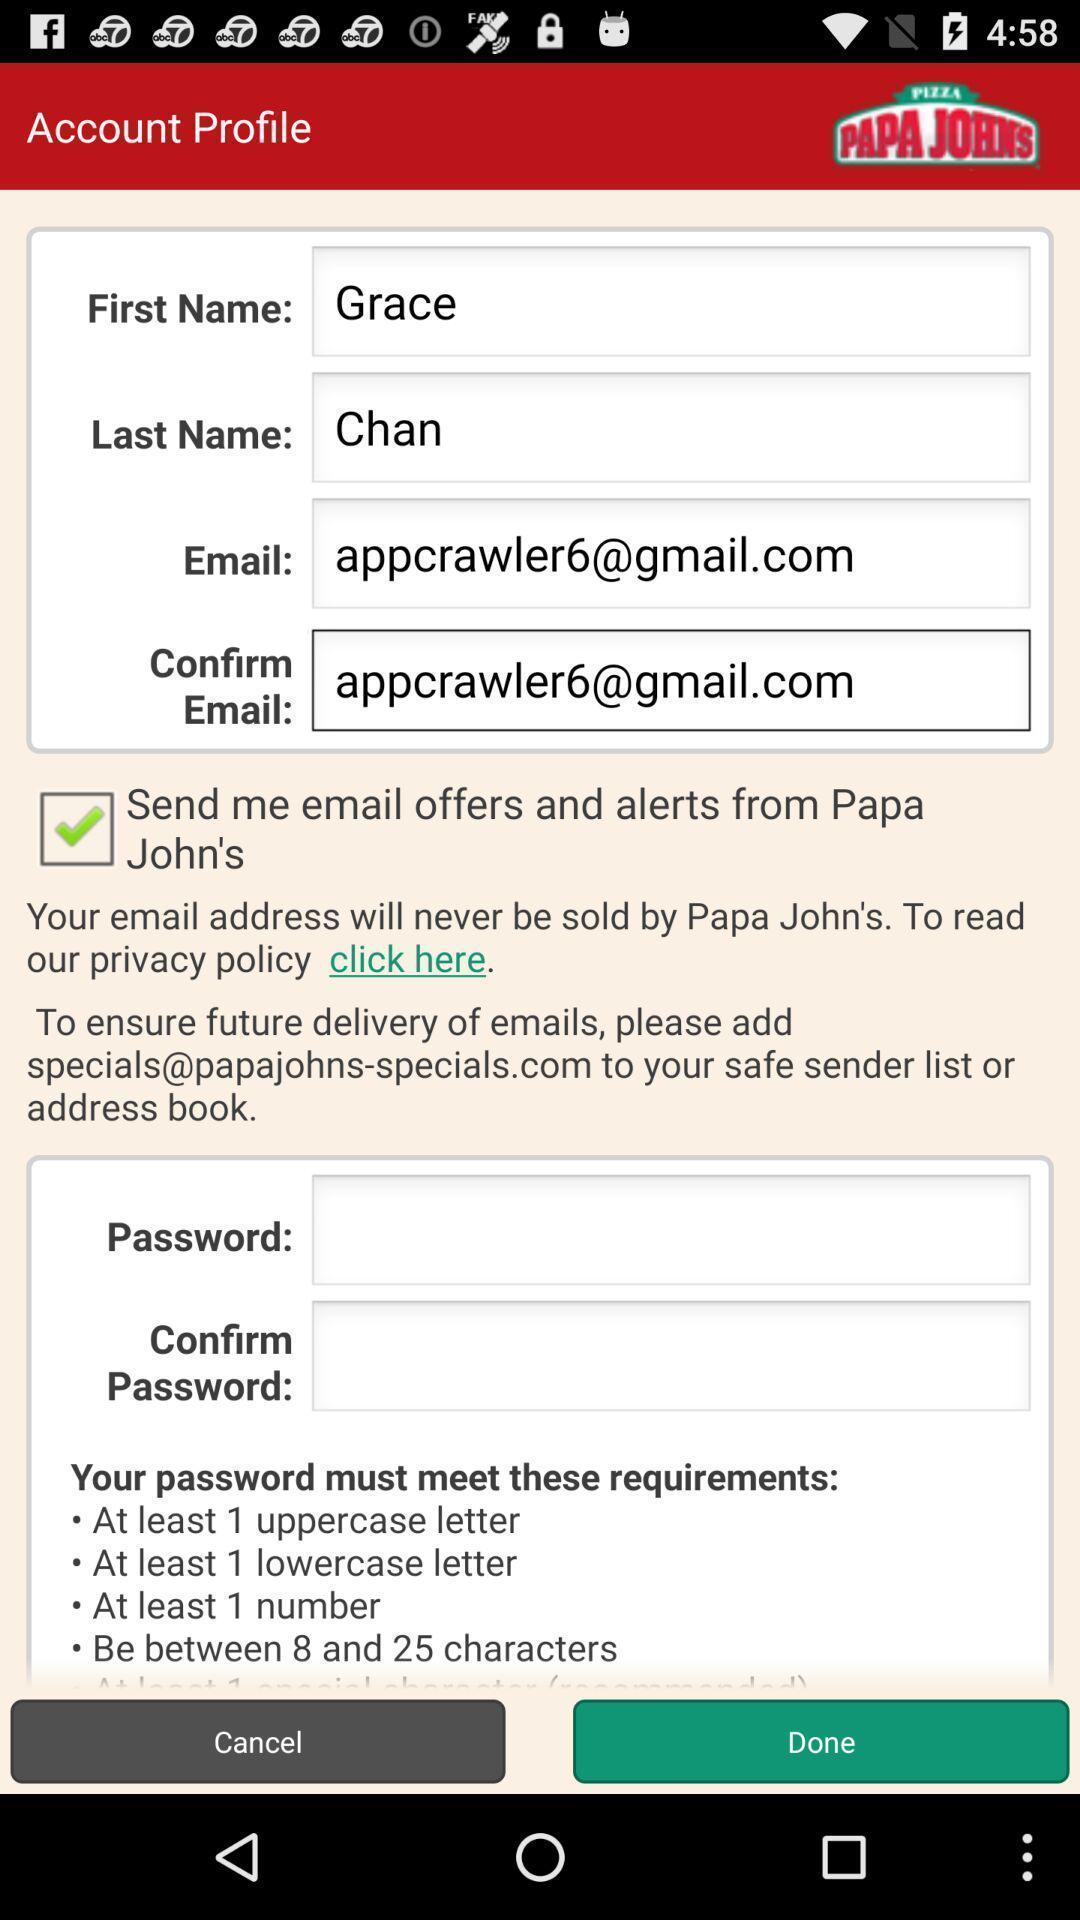Give me a summary of this screen capture. Screen displaying the account profile. 